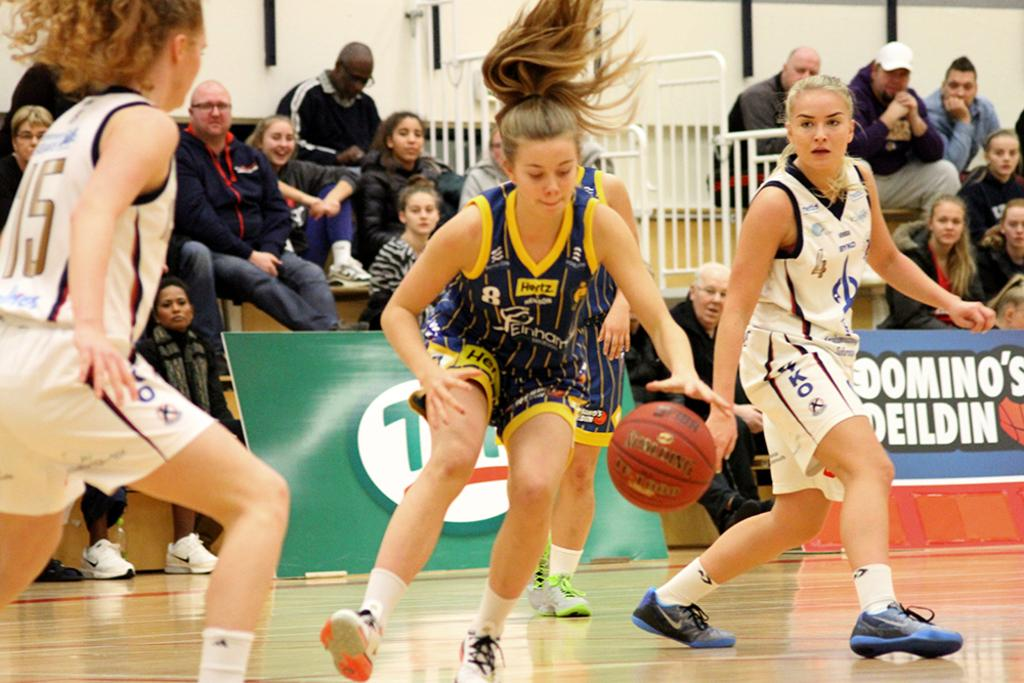Provide a one-sentence caption for the provided image. Several girls playing basketball in front of a crowd wear uniforms bearing the names of sponsors such as Hertz. 